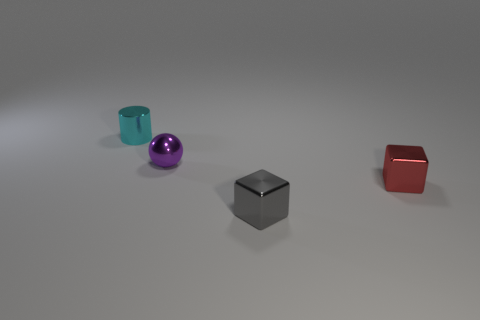What textures are visible on the objects and what does that suggest about their materials? Each object displays a distinct texture: the small sphere and the tiny cylinder have a smooth, glossy surface suggesting a polished metallic material, the cube appears to have a matte, almost brushed finish, while the red cube has a reflective, yet slightly textured surface that might imply a coated or painted metallic material. 